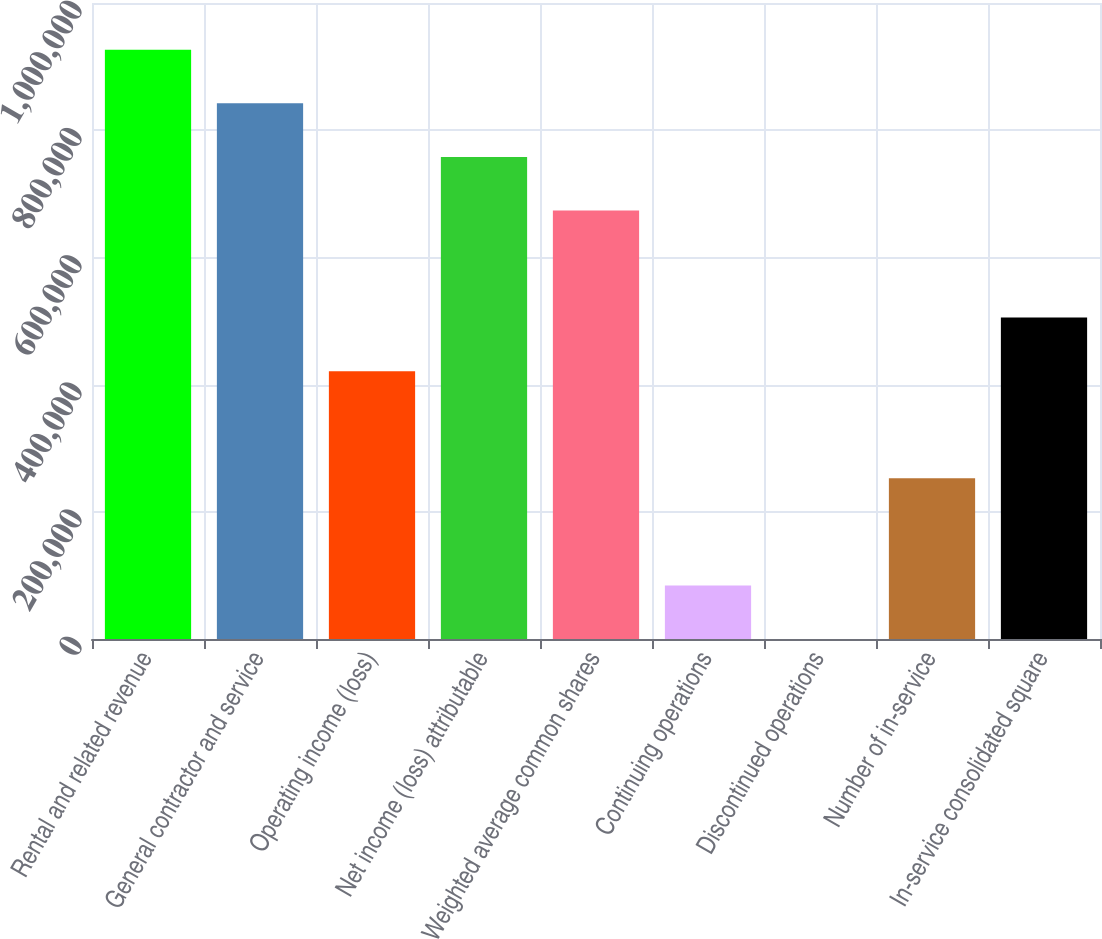Convert chart. <chart><loc_0><loc_0><loc_500><loc_500><bar_chart><fcel>Rental and related revenue<fcel>General contractor and service<fcel>Operating income (loss)<fcel>Net income (loss) attributable<fcel>Weighted average common shares<fcel>Continuing operations<fcel>Discontinued operations<fcel>Number of in-service<fcel>In-service consolidated square<nl><fcel>926455<fcel>842232<fcel>421116<fcel>758009<fcel>673786<fcel>84223.3<fcel>0.09<fcel>252670<fcel>505339<nl></chart> 